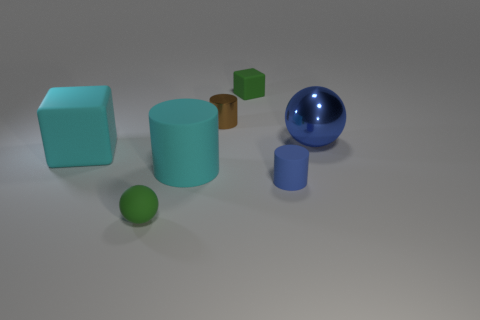Is the material of the big cube the same as the green object behind the blue ball?
Give a very brief answer. Yes. What color is the matte sphere?
Make the answer very short. Green. The tiny cylinder left of the small green matte object behind the green rubber thing that is in front of the metal cylinder is what color?
Give a very brief answer. Brown. Does the tiny blue matte object have the same shape as the metallic object that is right of the small brown thing?
Offer a very short reply. No. What is the color of the thing that is both behind the cyan matte block and in front of the brown cylinder?
Your answer should be compact. Blue. Is there a big blue thing that has the same shape as the tiny brown object?
Make the answer very short. No. Do the big metallic thing and the small rubber cube have the same color?
Provide a succinct answer. No. Are there any small green objects on the right side of the green rubber thing that is in front of the large metallic thing?
Provide a succinct answer. Yes. What number of things are either cubes in front of the small green rubber block or metal objects that are on the left side of the tiny block?
Ensure brevity in your answer.  2. What number of objects are either tiny brown things or small cylinders left of the tiny green matte block?
Ensure brevity in your answer.  1. 